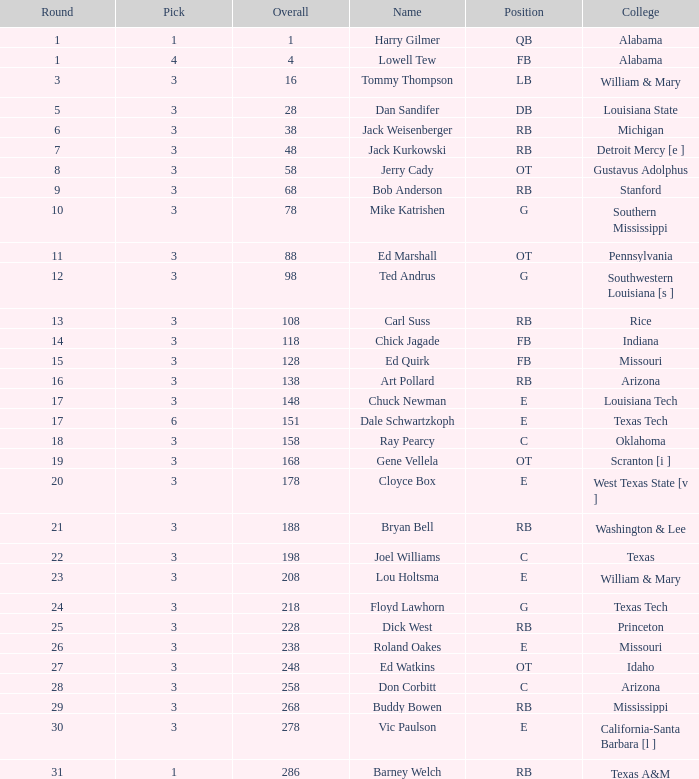What is stanford's overall average? 68.0. 